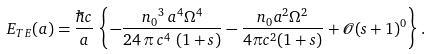<formula> <loc_0><loc_0><loc_500><loc_500>E _ { T E } ( a ) = \frac { \hbar { c } } { a } \, \left \{ - \frac { { n _ { 0 } } ^ { 3 } \, a ^ { 4 } \Omega ^ { 4 } } { 2 4 \, \pi \, c ^ { 4 } \, \left ( 1 + s \right ) } - \frac { n _ { 0 } a ^ { 2 } \Omega ^ { 2 } } { 4 \pi c ^ { 2 } ( 1 + s ) } + \mathcal { O } ( s + 1 ) ^ { 0 } \right \} .</formula> 